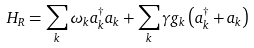Convert formula to latex. <formula><loc_0><loc_0><loc_500><loc_500>H _ { R } = \sum _ { k } \omega _ { k } a _ { k } ^ { \dagger } a _ { k } + \sum _ { k } \gamma g _ { k } \left ( a _ { k } ^ { \dagger } + a _ { k } \right )</formula> 